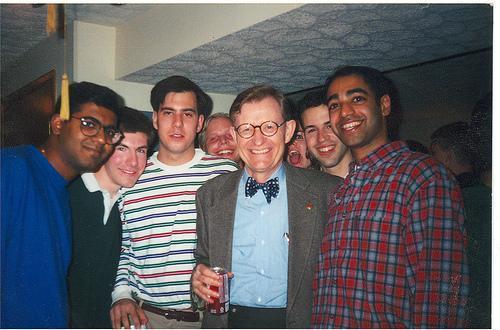How many people posing?
Give a very brief answer. 8. How many striped shirts?
Give a very brief answer. 1. How many pairs of eyeglasses?
Give a very brief answer. 2. 